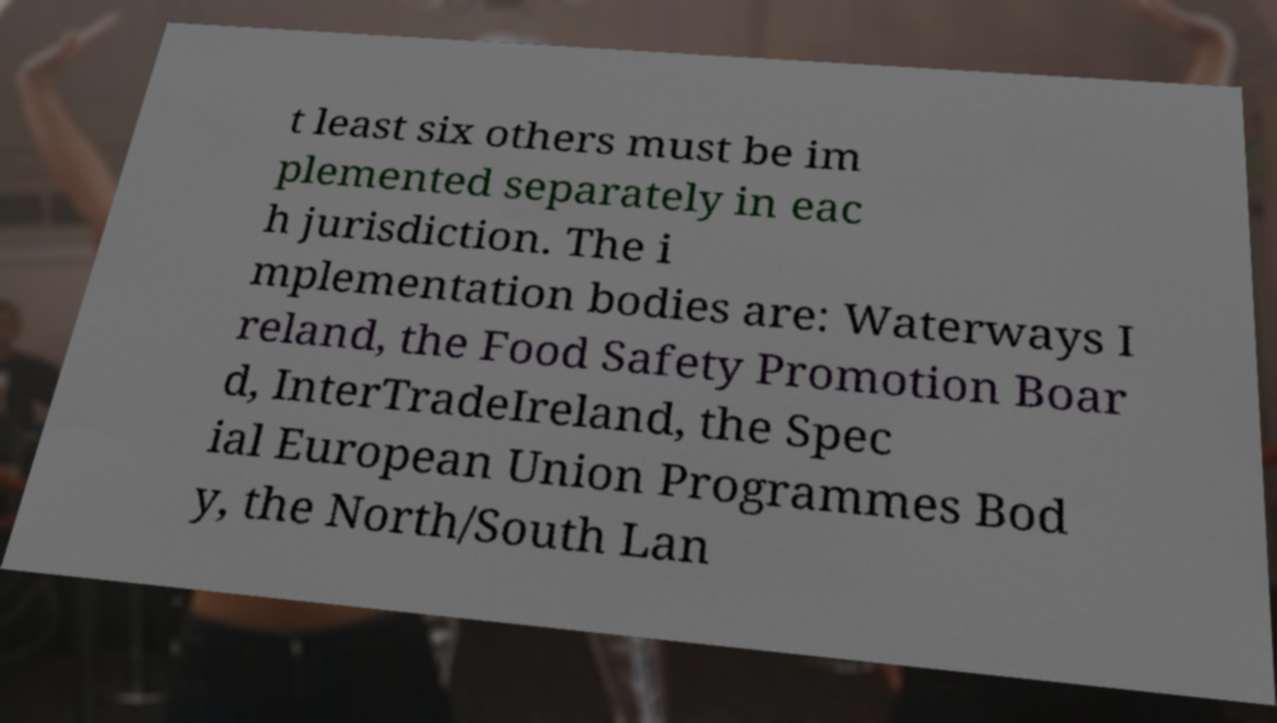What messages or text are displayed in this image? I need them in a readable, typed format. t least six others must be im plemented separately in eac h jurisdiction. The i mplementation bodies are: Waterways I reland, the Food Safety Promotion Boar d, InterTradeIreland, the Spec ial European Union Programmes Bod y, the North/South Lan 